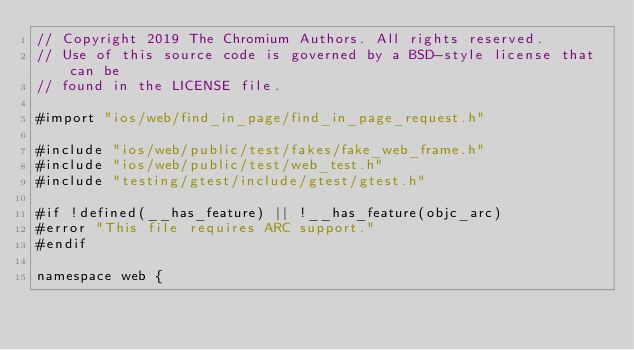Convert code to text. <code><loc_0><loc_0><loc_500><loc_500><_ObjectiveC_>// Copyright 2019 The Chromium Authors. All rights reserved.
// Use of this source code is governed by a BSD-style license that can be
// found in the LICENSE file.

#import "ios/web/find_in_page/find_in_page_request.h"

#include "ios/web/public/test/fakes/fake_web_frame.h"
#include "ios/web/public/test/web_test.h"
#include "testing/gtest/include/gtest/gtest.h"

#if !defined(__has_feature) || !__has_feature(objc_arc)
#error "This file requires ARC support."
#endif

namespace web {
</code> 